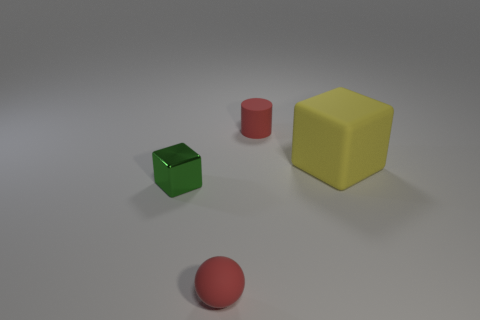Subtract all gray cylinders. Subtract all brown spheres. How many cylinders are left? 1 Add 2 small spheres. How many objects exist? 6 Subtract all cylinders. How many objects are left? 3 Subtract all yellow cubes. Subtract all yellow rubber things. How many objects are left? 2 Add 3 small green blocks. How many small green blocks are left? 4 Add 1 tiny metallic cylinders. How many tiny metallic cylinders exist? 1 Subtract 0 blue balls. How many objects are left? 4 